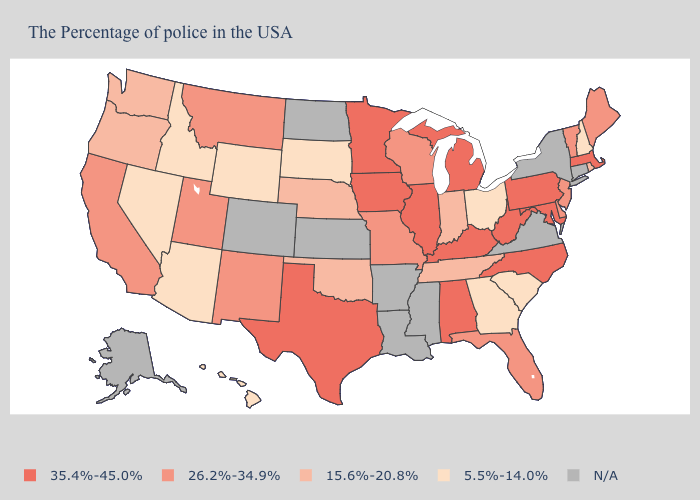Does the first symbol in the legend represent the smallest category?
Keep it brief. No. Does the map have missing data?
Concise answer only. Yes. Which states hav the highest value in the MidWest?
Short answer required. Michigan, Illinois, Minnesota, Iowa. Does the map have missing data?
Be succinct. Yes. What is the highest value in the USA?
Concise answer only. 35.4%-45.0%. What is the value of Massachusetts?
Quick response, please. 35.4%-45.0%. Among the states that border Ohio , does Indiana have the lowest value?
Short answer required. Yes. Among the states that border North Carolina , does South Carolina have the lowest value?
Keep it brief. Yes. What is the value of South Dakota?
Be succinct. 5.5%-14.0%. Which states have the highest value in the USA?
Be succinct. Massachusetts, Maryland, Pennsylvania, North Carolina, West Virginia, Michigan, Kentucky, Alabama, Illinois, Minnesota, Iowa, Texas. What is the value of Georgia?
Keep it brief. 5.5%-14.0%. What is the value of Missouri?
Short answer required. 26.2%-34.9%. What is the lowest value in the Northeast?
Give a very brief answer. 5.5%-14.0%. What is the highest value in states that border New York?
Answer briefly. 35.4%-45.0%. 